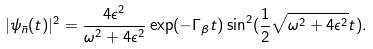<formula> <loc_0><loc_0><loc_500><loc_500>| \psi _ { \bar { n } } ( t ) | ^ { 2 } = \frac { 4 \epsilon ^ { 2 } } { \omega ^ { 2 } + 4 \epsilon ^ { 2 } } \exp ( - \Gamma _ { \beta } t ) \sin ^ { 2 } ( \frac { 1 } { 2 } \sqrt { \omega ^ { 2 } + 4 \epsilon ^ { 2 } } t ) .</formula> 